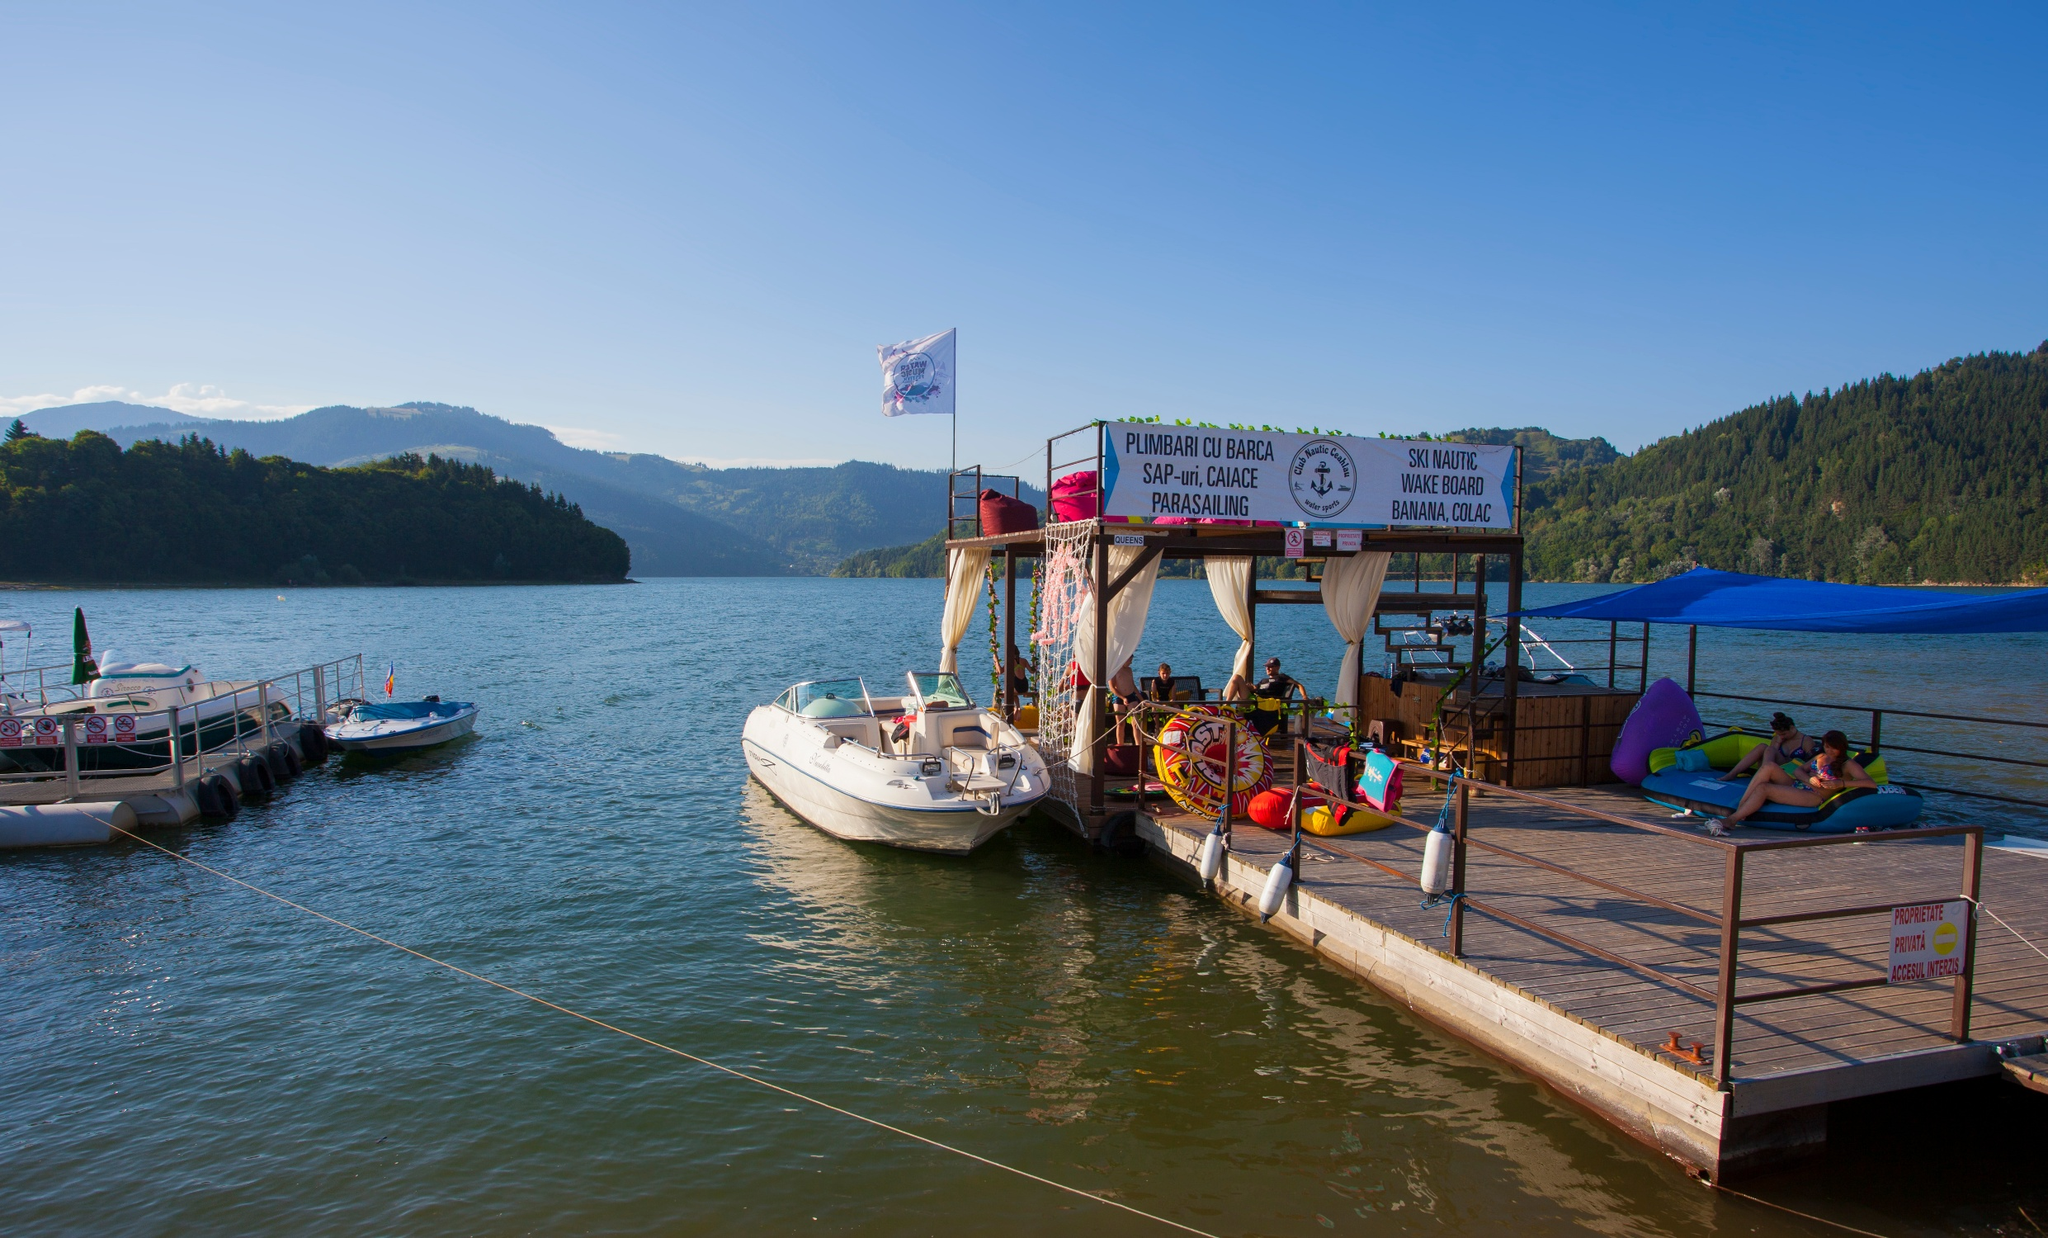What can you infer about the location from the image? The image seems to be from a tourist-friendly region, given the availability of water activities and the infrastructure to support them. The landscape with lush green hills suggests a location that could be either in a temperate region or possibly a popular holiday destination in a mountainous area. The text on the signage is not in English, which indicates it might be in a non-English-speaking country. The presence of the dock and operational businesses suggests this location is well-frequented by visitors. What might be the economic significance of this place? The area is likely a hub for local tourism, attracting visitors with its water sport facilities and scenic beauty. This drives the local economy, providing income through the rental of equipment, sale of refreshments, and potentially accommodations nearby. Such locations help create jobs for residents and can be significant for the economic vitality of the area. 